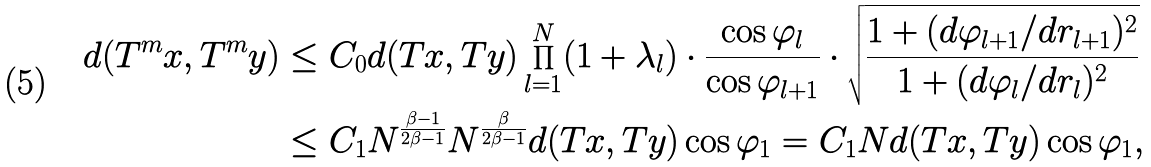<formula> <loc_0><loc_0><loc_500><loc_500>d ( T ^ { m } x , T ^ { m } y ) & \leq C _ { 0 } d ( T x , T y ) \prod _ { l = 1 } ^ { N } ( 1 + \lambda _ { l } ) \cdot \frac { \cos \varphi _ { l } } { \cos \varphi _ { l + 1 } } \cdot \sqrt { \frac { 1 + ( d \varphi _ { l + 1 } / d r _ { l + 1 } ) ^ { 2 } } { 1 + ( d \varphi _ { l } / d r _ { l } ) ^ { 2 } } } \\ & \leq C _ { 1 } N ^ { \frac { \beta - 1 } { 2 \beta - 1 } } N ^ { \frac { \beta } { 2 \beta - 1 } } d ( T x , T y ) \cos \varphi _ { 1 } = C _ { 1 } N d ( T x , T y ) \cos \varphi _ { 1 } ,</formula> 